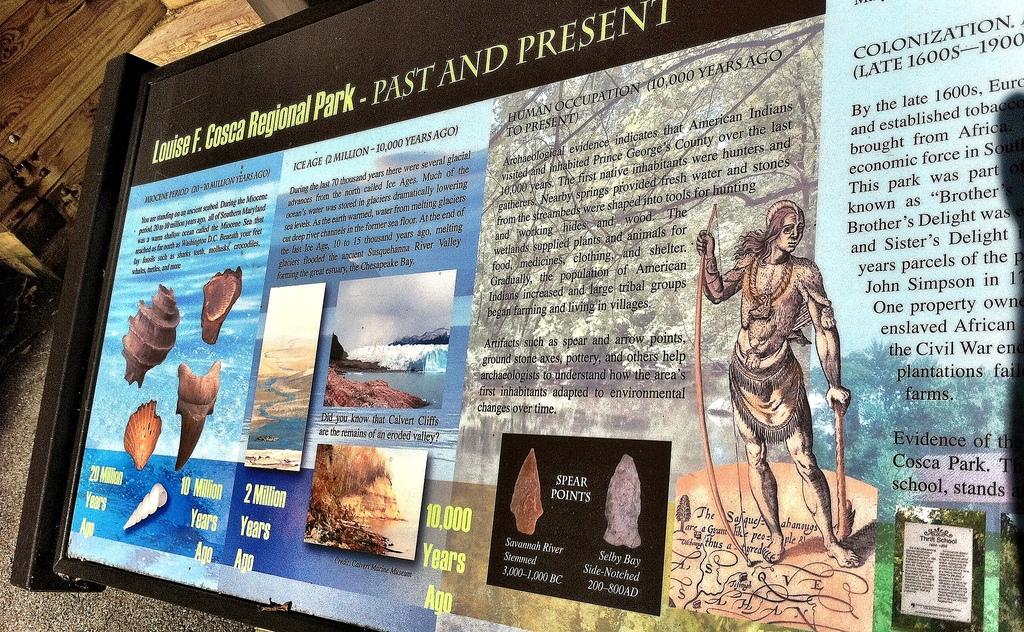What is written at the top in yellow?
Your response must be concise. Louise f. cosca regional park - past and present. 